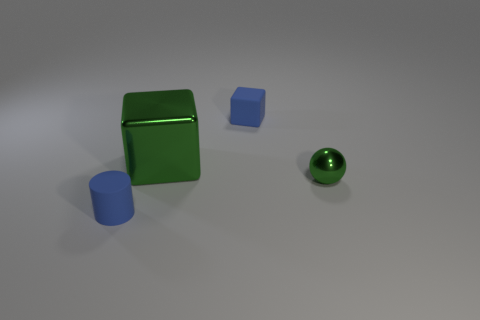Are there any other green balls that have the same size as the metal sphere?
Ensure brevity in your answer.  No. There is a small block; is its color the same as the tiny rubber thing in front of the small blue rubber block?
Give a very brief answer. Yes. What is the material of the blue cylinder?
Provide a short and direct response. Rubber. There is a metallic thing that is behind the green shiny ball; what color is it?
Ensure brevity in your answer.  Green. How many things have the same color as the matte cylinder?
Your response must be concise. 1. How many blue matte objects are left of the big green thing and behind the matte cylinder?
Offer a terse response. 0. What shape is the green object that is the same size as the blue matte cylinder?
Provide a short and direct response. Sphere. How big is the metal block?
Your answer should be compact. Large. The tiny blue thing that is in front of the small rubber object behind the small thing that is to the left of the tiny blue matte block is made of what material?
Your answer should be compact. Rubber. There is a small sphere that is made of the same material as the big green block; what color is it?
Your answer should be compact. Green. 